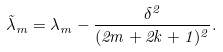<formula> <loc_0><loc_0><loc_500><loc_500>\tilde { \lambda } _ { m } = \lambda _ { m } - \frac { \delta ^ { 2 } } { ( 2 m + 2 k + 1 ) ^ { 2 } } .</formula> 